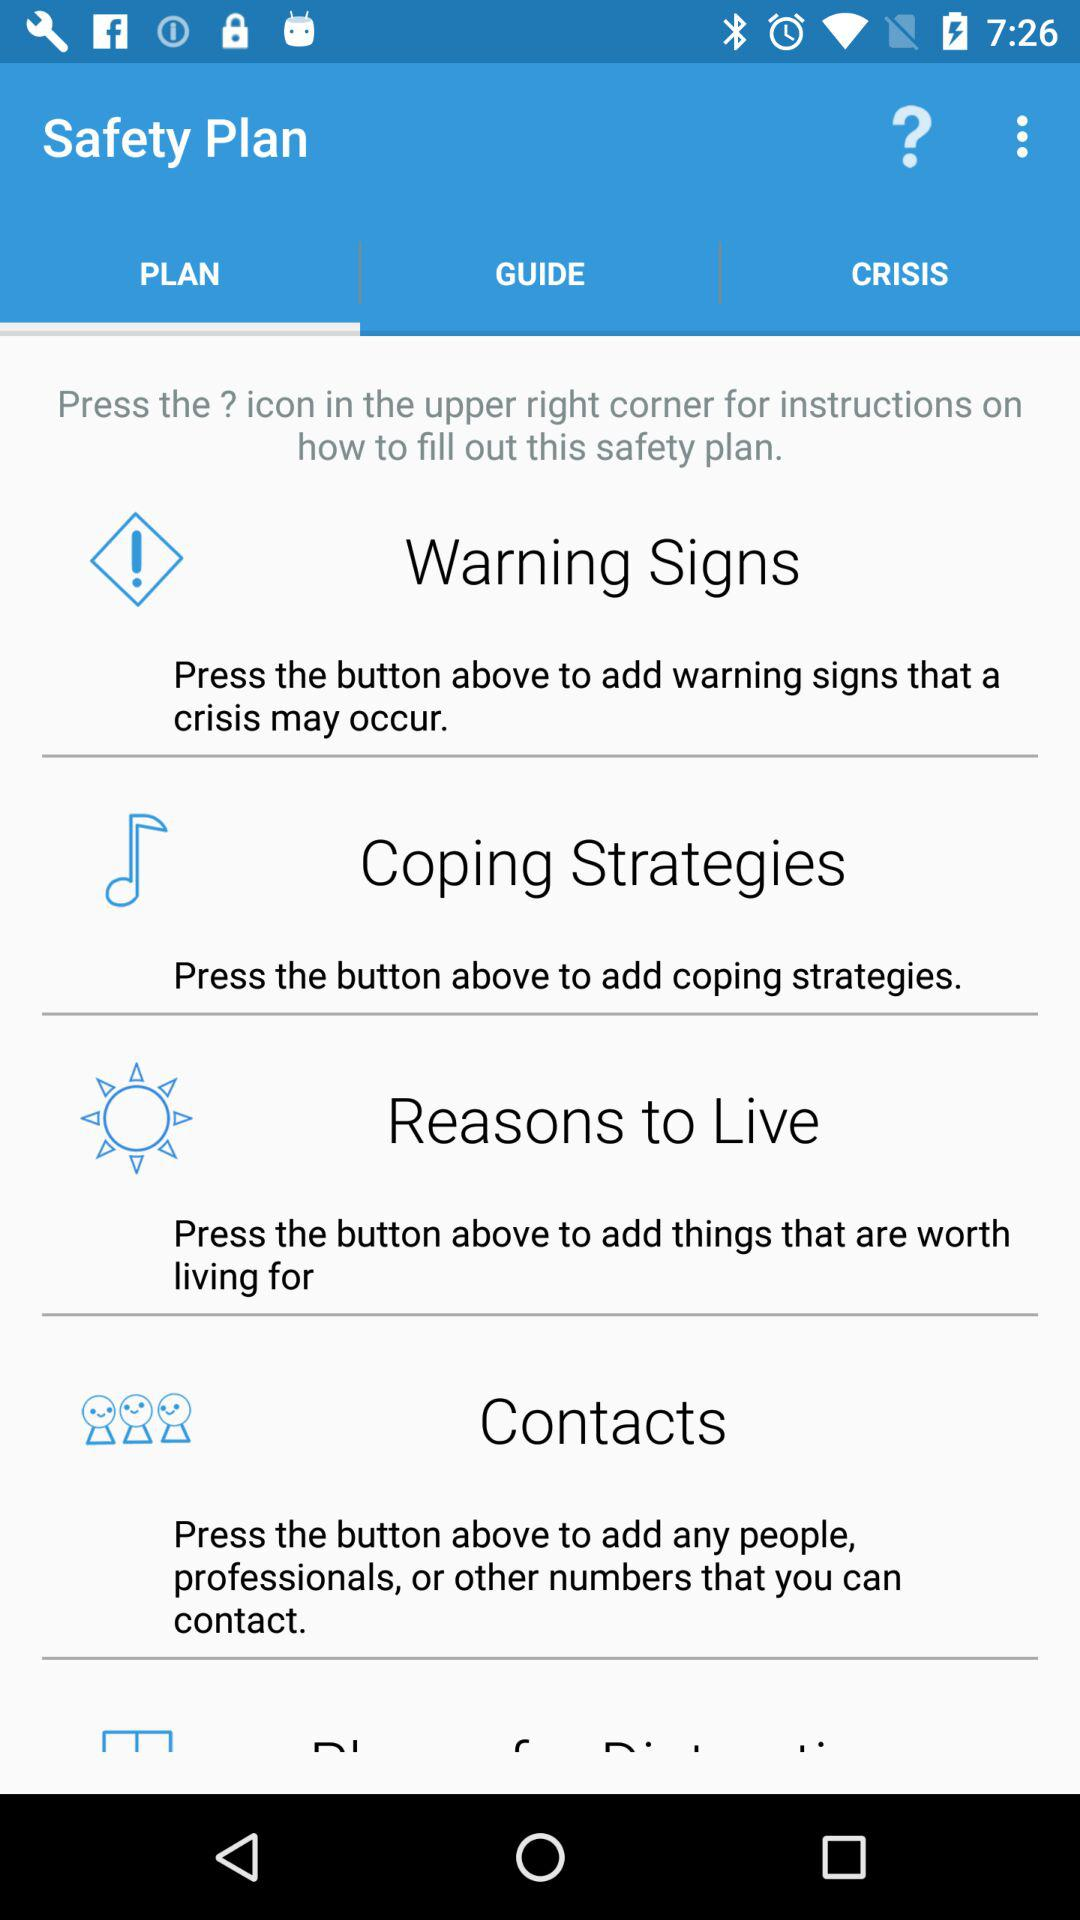Which tab is selected in the "Safety Plan"? The selected tab is "PLAN". 